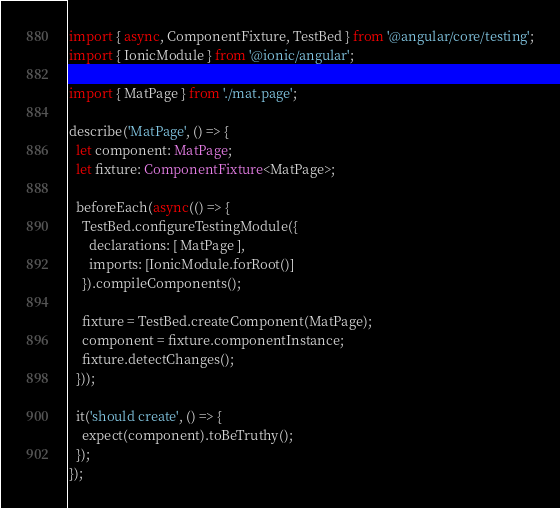Convert code to text. <code><loc_0><loc_0><loc_500><loc_500><_TypeScript_>import { async, ComponentFixture, TestBed } from '@angular/core/testing';
import { IonicModule } from '@ionic/angular';

import { MatPage } from './mat.page';

describe('MatPage', () => {
  let component: MatPage;
  let fixture: ComponentFixture<MatPage>;

  beforeEach(async(() => {
    TestBed.configureTestingModule({
      declarations: [ MatPage ],
      imports: [IonicModule.forRoot()]
    }).compileComponents();

    fixture = TestBed.createComponent(MatPage);
    component = fixture.componentInstance;
    fixture.detectChanges();
  }));

  it('should create', () => {
    expect(component).toBeTruthy();
  });
});
</code> 